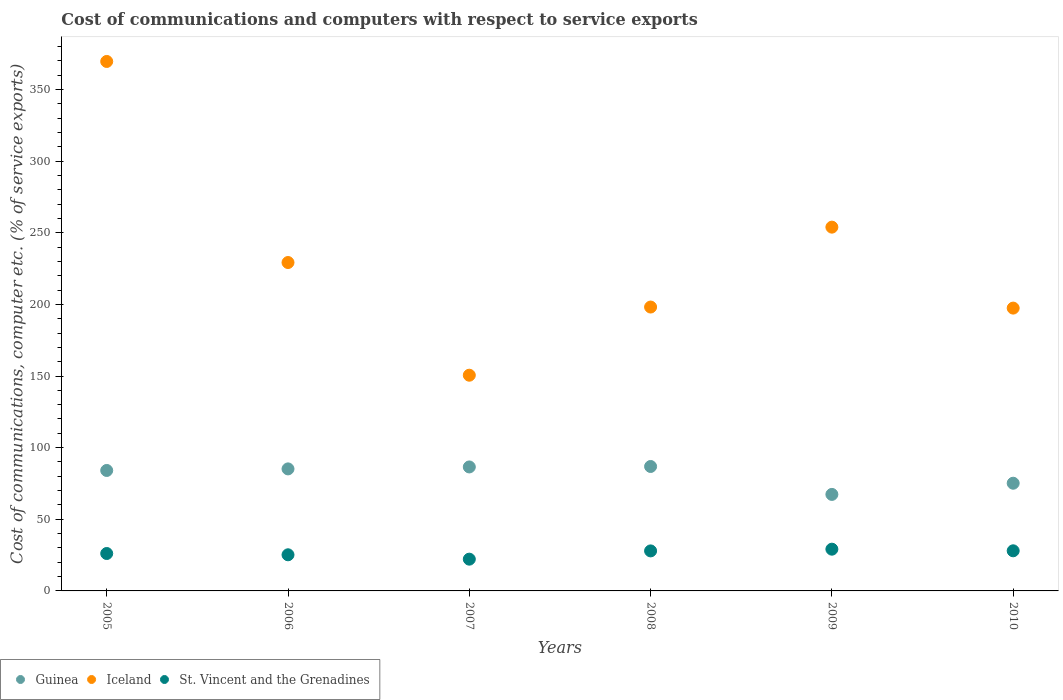How many different coloured dotlines are there?
Ensure brevity in your answer.  3. Is the number of dotlines equal to the number of legend labels?
Keep it short and to the point. Yes. What is the cost of communications and computers in St. Vincent and the Grenadines in 2008?
Ensure brevity in your answer.  27.93. Across all years, what is the maximum cost of communications and computers in Iceland?
Your answer should be very brief. 369.54. Across all years, what is the minimum cost of communications and computers in Guinea?
Your response must be concise. 67.36. In which year was the cost of communications and computers in St. Vincent and the Grenadines minimum?
Your answer should be compact. 2007. What is the total cost of communications and computers in Guinea in the graph?
Offer a very short reply. 485.15. What is the difference between the cost of communications and computers in Guinea in 2008 and that in 2009?
Offer a very short reply. 19.49. What is the difference between the cost of communications and computers in Iceland in 2006 and the cost of communications and computers in St. Vincent and the Grenadines in 2007?
Ensure brevity in your answer.  207.04. What is the average cost of communications and computers in Iceland per year?
Provide a short and direct response. 233.12. In the year 2009, what is the difference between the cost of communications and computers in Iceland and cost of communications and computers in Guinea?
Make the answer very short. 186.54. What is the ratio of the cost of communications and computers in St. Vincent and the Grenadines in 2006 to that in 2009?
Make the answer very short. 0.87. Is the difference between the cost of communications and computers in Iceland in 2009 and 2010 greater than the difference between the cost of communications and computers in Guinea in 2009 and 2010?
Your answer should be compact. Yes. What is the difference between the highest and the second highest cost of communications and computers in St. Vincent and the Grenadines?
Your response must be concise. 1.13. What is the difference between the highest and the lowest cost of communications and computers in St. Vincent and the Grenadines?
Give a very brief answer. 6.97. Is it the case that in every year, the sum of the cost of communications and computers in St. Vincent and the Grenadines and cost of communications and computers in Iceland  is greater than the cost of communications and computers in Guinea?
Ensure brevity in your answer.  Yes. Does the cost of communications and computers in Guinea monotonically increase over the years?
Provide a succinct answer. No. What is the difference between two consecutive major ticks on the Y-axis?
Your response must be concise. 50. Are the values on the major ticks of Y-axis written in scientific E-notation?
Offer a terse response. No. Does the graph contain any zero values?
Keep it short and to the point. No. Does the graph contain grids?
Make the answer very short. No. How many legend labels are there?
Provide a succinct answer. 3. How are the legend labels stacked?
Offer a very short reply. Horizontal. What is the title of the graph?
Make the answer very short. Cost of communications and computers with respect to service exports. Does "World" appear as one of the legend labels in the graph?
Provide a short and direct response. No. What is the label or title of the X-axis?
Your answer should be compact. Years. What is the label or title of the Y-axis?
Provide a succinct answer. Cost of communications, computer etc. (% of service exports). What is the Cost of communications, computer etc. (% of service exports) of Guinea in 2005?
Offer a terse response. 84.08. What is the Cost of communications, computer etc. (% of service exports) in Iceland in 2005?
Provide a short and direct response. 369.54. What is the Cost of communications, computer etc. (% of service exports) in St. Vincent and the Grenadines in 2005?
Give a very brief answer. 26.12. What is the Cost of communications, computer etc. (% of service exports) in Guinea in 2006?
Your response must be concise. 85.17. What is the Cost of communications, computer etc. (% of service exports) in Iceland in 2006?
Provide a succinct answer. 229.21. What is the Cost of communications, computer etc. (% of service exports) in St. Vincent and the Grenadines in 2006?
Make the answer very short. 25.22. What is the Cost of communications, computer etc. (% of service exports) of Guinea in 2007?
Give a very brief answer. 86.53. What is the Cost of communications, computer etc. (% of service exports) of Iceland in 2007?
Keep it short and to the point. 150.55. What is the Cost of communications, computer etc. (% of service exports) of St. Vincent and the Grenadines in 2007?
Provide a short and direct response. 22.17. What is the Cost of communications, computer etc. (% of service exports) in Guinea in 2008?
Your answer should be very brief. 86.85. What is the Cost of communications, computer etc. (% of service exports) in Iceland in 2008?
Give a very brief answer. 198.13. What is the Cost of communications, computer etc. (% of service exports) of St. Vincent and the Grenadines in 2008?
Offer a very short reply. 27.93. What is the Cost of communications, computer etc. (% of service exports) in Guinea in 2009?
Keep it short and to the point. 67.36. What is the Cost of communications, computer etc. (% of service exports) in Iceland in 2009?
Provide a succinct answer. 253.9. What is the Cost of communications, computer etc. (% of service exports) in St. Vincent and the Grenadines in 2009?
Provide a succinct answer. 29.14. What is the Cost of communications, computer etc. (% of service exports) in Guinea in 2010?
Offer a very short reply. 75.16. What is the Cost of communications, computer etc. (% of service exports) of Iceland in 2010?
Keep it short and to the point. 197.4. What is the Cost of communications, computer etc. (% of service exports) in St. Vincent and the Grenadines in 2010?
Make the answer very short. 28. Across all years, what is the maximum Cost of communications, computer etc. (% of service exports) of Guinea?
Make the answer very short. 86.85. Across all years, what is the maximum Cost of communications, computer etc. (% of service exports) in Iceland?
Keep it short and to the point. 369.54. Across all years, what is the maximum Cost of communications, computer etc. (% of service exports) of St. Vincent and the Grenadines?
Provide a succinct answer. 29.14. Across all years, what is the minimum Cost of communications, computer etc. (% of service exports) in Guinea?
Provide a succinct answer. 67.36. Across all years, what is the minimum Cost of communications, computer etc. (% of service exports) in Iceland?
Your response must be concise. 150.55. Across all years, what is the minimum Cost of communications, computer etc. (% of service exports) in St. Vincent and the Grenadines?
Provide a short and direct response. 22.17. What is the total Cost of communications, computer etc. (% of service exports) of Guinea in the graph?
Make the answer very short. 485.15. What is the total Cost of communications, computer etc. (% of service exports) of Iceland in the graph?
Offer a very short reply. 1398.74. What is the total Cost of communications, computer etc. (% of service exports) in St. Vincent and the Grenadines in the graph?
Ensure brevity in your answer.  158.57. What is the difference between the Cost of communications, computer etc. (% of service exports) in Guinea in 2005 and that in 2006?
Make the answer very short. -1.09. What is the difference between the Cost of communications, computer etc. (% of service exports) in Iceland in 2005 and that in 2006?
Make the answer very short. 140.33. What is the difference between the Cost of communications, computer etc. (% of service exports) in St. Vincent and the Grenadines in 2005 and that in 2006?
Provide a short and direct response. 0.9. What is the difference between the Cost of communications, computer etc. (% of service exports) of Guinea in 2005 and that in 2007?
Offer a terse response. -2.45. What is the difference between the Cost of communications, computer etc. (% of service exports) of Iceland in 2005 and that in 2007?
Keep it short and to the point. 218.99. What is the difference between the Cost of communications, computer etc. (% of service exports) of St. Vincent and the Grenadines in 2005 and that in 2007?
Provide a short and direct response. 3.95. What is the difference between the Cost of communications, computer etc. (% of service exports) in Guinea in 2005 and that in 2008?
Provide a succinct answer. -2.78. What is the difference between the Cost of communications, computer etc. (% of service exports) in Iceland in 2005 and that in 2008?
Give a very brief answer. 171.41. What is the difference between the Cost of communications, computer etc. (% of service exports) in St. Vincent and the Grenadines in 2005 and that in 2008?
Give a very brief answer. -1.81. What is the difference between the Cost of communications, computer etc. (% of service exports) of Guinea in 2005 and that in 2009?
Your response must be concise. 16.72. What is the difference between the Cost of communications, computer etc. (% of service exports) of Iceland in 2005 and that in 2009?
Provide a succinct answer. 115.64. What is the difference between the Cost of communications, computer etc. (% of service exports) in St. Vincent and the Grenadines in 2005 and that in 2009?
Your answer should be compact. -3.02. What is the difference between the Cost of communications, computer etc. (% of service exports) in Guinea in 2005 and that in 2010?
Give a very brief answer. 8.91. What is the difference between the Cost of communications, computer etc. (% of service exports) of Iceland in 2005 and that in 2010?
Your answer should be very brief. 172.15. What is the difference between the Cost of communications, computer etc. (% of service exports) in St. Vincent and the Grenadines in 2005 and that in 2010?
Offer a very short reply. -1.89. What is the difference between the Cost of communications, computer etc. (% of service exports) in Guinea in 2006 and that in 2007?
Provide a short and direct response. -1.36. What is the difference between the Cost of communications, computer etc. (% of service exports) of Iceland in 2006 and that in 2007?
Make the answer very short. 78.66. What is the difference between the Cost of communications, computer etc. (% of service exports) in St. Vincent and the Grenadines in 2006 and that in 2007?
Give a very brief answer. 3.05. What is the difference between the Cost of communications, computer etc. (% of service exports) of Guinea in 2006 and that in 2008?
Keep it short and to the point. -1.68. What is the difference between the Cost of communications, computer etc. (% of service exports) in Iceland in 2006 and that in 2008?
Keep it short and to the point. 31.08. What is the difference between the Cost of communications, computer etc. (% of service exports) of St. Vincent and the Grenadines in 2006 and that in 2008?
Make the answer very short. -2.71. What is the difference between the Cost of communications, computer etc. (% of service exports) in Guinea in 2006 and that in 2009?
Ensure brevity in your answer.  17.81. What is the difference between the Cost of communications, computer etc. (% of service exports) in Iceland in 2006 and that in 2009?
Your response must be concise. -24.69. What is the difference between the Cost of communications, computer etc. (% of service exports) of St. Vincent and the Grenadines in 2006 and that in 2009?
Provide a short and direct response. -3.92. What is the difference between the Cost of communications, computer etc. (% of service exports) of Guinea in 2006 and that in 2010?
Your answer should be compact. 10. What is the difference between the Cost of communications, computer etc. (% of service exports) in Iceland in 2006 and that in 2010?
Your response must be concise. 31.82. What is the difference between the Cost of communications, computer etc. (% of service exports) in St. Vincent and the Grenadines in 2006 and that in 2010?
Offer a very short reply. -2.79. What is the difference between the Cost of communications, computer etc. (% of service exports) of Guinea in 2007 and that in 2008?
Keep it short and to the point. -0.32. What is the difference between the Cost of communications, computer etc. (% of service exports) in Iceland in 2007 and that in 2008?
Provide a short and direct response. -47.58. What is the difference between the Cost of communications, computer etc. (% of service exports) of St. Vincent and the Grenadines in 2007 and that in 2008?
Offer a very short reply. -5.76. What is the difference between the Cost of communications, computer etc. (% of service exports) in Guinea in 2007 and that in 2009?
Your answer should be very brief. 19.17. What is the difference between the Cost of communications, computer etc. (% of service exports) of Iceland in 2007 and that in 2009?
Your answer should be very brief. -103.35. What is the difference between the Cost of communications, computer etc. (% of service exports) of St. Vincent and the Grenadines in 2007 and that in 2009?
Offer a very short reply. -6.97. What is the difference between the Cost of communications, computer etc. (% of service exports) of Guinea in 2007 and that in 2010?
Your response must be concise. 11.37. What is the difference between the Cost of communications, computer etc. (% of service exports) of Iceland in 2007 and that in 2010?
Your answer should be very brief. -46.84. What is the difference between the Cost of communications, computer etc. (% of service exports) of St. Vincent and the Grenadines in 2007 and that in 2010?
Offer a very short reply. -5.83. What is the difference between the Cost of communications, computer etc. (% of service exports) in Guinea in 2008 and that in 2009?
Provide a succinct answer. 19.49. What is the difference between the Cost of communications, computer etc. (% of service exports) in Iceland in 2008 and that in 2009?
Make the answer very short. -55.77. What is the difference between the Cost of communications, computer etc. (% of service exports) of St. Vincent and the Grenadines in 2008 and that in 2009?
Ensure brevity in your answer.  -1.21. What is the difference between the Cost of communications, computer etc. (% of service exports) of Guinea in 2008 and that in 2010?
Your answer should be very brief. 11.69. What is the difference between the Cost of communications, computer etc. (% of service exports) of Iceland in 2008 and that in 2010?
Offer a terse response. 0.74. What is the difference between the Cost of communications, computer etc. (% of service exports) of St. Vincent and the Grenadines in 2008 and that in 2010?
Provide a succinct answer. -0.07. What is the difference between the Cost of communications, computer etc. (% of service exports) of Guinea in 2009 and that in 2010?
Provide a succinct answer. -7.81. What is the difference between the Cost of communications, computer etc. (% of service exports) in Iceland in 2009 and that in 2010?
Your answer should be compact. 56.51. What is the difference between the Cost of communications, computer etc. (% of service exports) in St. Vincent and the Grenadines in 2009 and that in 2010?
Offer a very short reply. 1.13. What is the difference between the Cost of communications, computer etc. (% of service exports) in Guinea in 2005 and the Cost of communications, computer etc. (% of service exports) in Iceland in 2006?
Offer a terse response. -145.14. What is the difference between the Cost of communications, computer etc. (% of service exports) in Guinea in 2005 and the Cost of communications, computer etc. (% of service exports) in St. Vincent and the Grenadines in 2006?
Provide a succinct answer. 58.86. What is the difference between the Cost of communications, computer etc. (% of service exports) of Iceland in 2005 and the Cost of communications, computer etc. (% of service exports) of St. Vincent and the Grenadines in 2006?
Provide a succinct answer. 344.33. What is the difference between the Cost of communications, computer etc. (% of service exports) in Guinea in 2005 and the Cost of communications, computer etc. (% of service exports) in Iceland in 2007?
Provide a short and direct response. -66.48. What is the difference between the Cost of communications, computer etc. (% of service exports) in Guinea in 2005 and the Cost of communications, computer etc. (% of service exports) in St. Vincent and the Grenadines in 2007?
Your response must be concise. 61.91. What is the difference between the Cost of communications, computer etc. (% of service exports) in Iceland in 2005 and the Cost of communications, computer etc. (% of service exports) in St. Vincent and the Grenadines in 2007?
Your answer should be compact. 347.37. What is the difference between the Cost of communications, computer etc. (% of service exports) of Guinea in 2005 and the Cost of communications, computer etc. (% of service exports) of Iceland in 2008?
Give a very brief answer. -114.06. What is the difference between the Cost of communications, computer etc. (% of service exports) of Guinea in 2005 and the Cost of communications, computer etc. (% of service exports) of St. Vincent and the Grenadines in 2008?
Offer a terse response. 56.15. What is the difference between the Cost of communications, computer etc. (% of service exports) of Iceland in 2005 and the Cost of communications, computer etc. (% of service exports) of St. Vincent and the Grenadines in 2008?
Provide a succinct answer. 341.61. What is the difference between the Cost of communications, computer etc. (% of service exports) in Guinea in 2005 and the Cost of communications, computer etc. (% of service exports) in Iceland in 2009?
Offer a terse response. -169.83. What is the difference between the Cost of communications, computer etc. (% of service exports) in Guinea in 2005 and the Cost of communications, computer etc. (% of service exports) in St. Vincent and the Grenadines in 2009?
Provide a succinct answer. 54.94. What is the difference between the Cost of communications, computer etc. (% of service exports) in Iceland in 2005 and the Cost of communications, computer etc. (% of service exports) in St. Vincent and the Grenadines in 2009?
Your answer should be compact. 340.41. What is the difference between the Cost of communications, computer etc. (% of service exports) in Guinea in 2005 and the Cost of communications, computer etc. (% of service exports) in Iceland in 2010?
Give a very brief answer. -113.32. What is the difference between the Cost of communications, computer etc. (% of service exports) of Guinea in 2005 and the Cost of communications, computer etc. (% of service exports) of St. Vincent and the Grenadines in 2010?
Give a very brief answer. 56.07. What is the difference between the Cost of communications, computer etc. (% of service exports) in Iceland in 2005 and the Cost of communications, computer etc. (% of service exports) in St. Vincent and the Grenadines in 2010?
Make the answer very short. 341.54. What is the difference between the Cost of communications, computer etc. (% of service exports) in Guinea in 2006 and the Cost of communications, computer etc. (% of service exports) in Iceland in 2007?
Offer a very short reply. -65.39. What is the difference between the Cost of communications, computer etc. (% of service exports) in Guinea in 2006 and the Cost of communications, computer etc. (% of service exports) in St. Vincent and the Grenadines in 2007?
Ensure brevity in your answer.  63. What is the difference between the Cost of communications, computer etc. (% of service exports) in Iceland in 2006 and the Cost of communications, computer etc. (% of service exports) in St. Vincent and the Grenadines in 2007?
Provide a short and direct response. 207.04. What is the difference between the Cost of communications, computer etc. (% of service exports) of Guinea in 2006 and the Cost of communications, computer etc. (% of service exports) of Iceland in 2008?
Keep it short and to the point. -112.97. What is the difference between the Cost of communications, computer etc. (% of service exports) of Guinea in 2006 and the Cost of communications, computer etc. (% of service exports) of St. Vincent and the Grenadines in 2008?
Provide a short and direct response. 57.24. What is the difference between the Cost of communications, computer etc. (% of service exports) in Iceland in 2006 and the Cost of communications, computer etc. (% of service exports) in St. Vincent and the Grenadines in 2008?
Offer a very short reply. 201.28. What is the difference between the Cost of communications, computer etc. (% of service exports) of Guinea in 2006 and the Cost of communications, computer etc. (% of service exports) of Iceland in 2009?
Provide a succinct answer. -168.73. What is the difference between the Cost of communications, computer etc. (% of service exports) of Guinea in 2006 and the Cost of communications, computer etc. (% of service exports) of St. Vincent and the Grenadines in 2009?
Make the answer very short. 56.03. What is the difference between the Cost of communications, computer etc. (% of service exports) in Iceland in 2006 and the Cost of communications, computer etc. (% of service exports) in St. Vincent and the Grenadines in 2009?
Provide a succinct answer. 200.08. What is the difference between the Cost of communications, computer etc. (% of service exports) in Guinea in 2006 and the Cost of communications, computer etc. (% of service exports) in Iceland in 2010?
Ensure brevity in your answer.  -112.23. What is the difference between the Cost of communications, computer etc. (% of service exports) in Guinea in 2006 and the Cost of communications, computer etc. (% of service exports) in St. Vincent and the Grenadines in 2010?
Your response must be concise. 57.16. What is the difference between the Cost of communications, computer etc. (% of service exports) in Iceland in 2006 and the Cost of communications, computer etc. (% of service exports) in St. Vincent and the Grenadines in 2010?
Offer a terse response. 201.21. What is the difference between the Cost of communications, computer etc. (% of service exports) of Guinea in 2007 and the Cost of communications, computer etc. (% of service exports) of Iceland in 2008?
Your answer should be compact. -111.6. What is the difference between the Cost of communications, computer etc. (% of service exports) in Guinea in 2007 and the Cost of communications, computer etc. (% of service exports) in St. Vincent and the Grenadines in 2008?
Your response must be concise. 58.6. What is the difference between the Cost of communications, computer etc. (% of service exports) of Iceland in 2007 and the Cost of communications, computer etc. (% of service exports) of St. Vincent and the Grenadines in 2008?
Offer a very short reply. 122.62. What is the difference between the Cost of communications, computer etc. (% of service exports) of Guinea in 2007 and the Cost of communications, computer etc. (% of service exports) of Iceland in 2009?
Offer a terse response. -167.37. What is the difference between the Cost of communications, computer etc. (% of service exports) of Guinea in 2007 and the Cost of communications, computer etc. (% of service exports) of St. Vincent and the Grenadines in 2009?
Provide a succinct answer. 57.39. What is the difference between the Cost of communications, computer etc. (% of service exports) in Iceland in 2007 and the Cost of communications, computer etc. (% of service exports) in St. Vincent and the Grenadines in 2009?
Provide a succinct answer. 121.42. What is the difference between the Cost of communications, computer etc. (% of service exports) of Guinea in 2007 and the Cost of communications, computer etc. (% of service exports) of Iceland in 2010?
Your answer should be very brief. -110.87. What is the difference between the Cost of communications, computer etc. (% of service exports) of Guinea in 2007 and the Cost of communications, computer etc. (% of service exports) of St. Vincent and the Grenadines in 2010?
Ensure brevity in your answer.  58.53. What is the difference between the Cost of communications, computer etc. (% of service exports) in Iceland in 2007 and the Cost of communications, computer etc. (% of service exports) in St. Vincent and the Grenadines in 2010?
Make the answer very short. 122.55. What is the difference between the Cost of communications, computer etc. (% of service exports) of Guinea in 2008 and the Cost of communications, computer etc. (% of service exports) of Iceland in 2009?
Make the answer very short. -167.05. What is the difference between the Cost of communications, computer etc. (% of service exports) of Guinea in 2008 and the Cost of communications, computer etc. (% of service exports) of St. Vincent and the Grenadines in 2009?
Keep it short and to the point. 57.72. What is the difference between the Cost of communications, computer etc. (% of service exports) of Iceland in 2008 and the Cost of communications, computer etc. (% of service exports) of St. Vincent and the Grenadines in 2009?
Offer a very short reply. 169. What is the difference between the Cost of communications, computer etc. (% of service exports) in Guinea in 2008 and the Cost of communications, computer etc. (% of service exports) in Iceland in 2010?
Give a very brief answer. -110.54. What is the difference between the Cost of communications, computer etc. (% of service exports) in Guinea in 2008 and the Cost of communications, computer etc. (% of service exports) in St. Vincent and the Grenadines in 2010?
Your answer should be compact. 58.85. What is the difference between the Cost of communications, computer etc. (% of service exports) in Iceland in 2008 and the Cost of communications, computer etc. (% of service exports) in St. Vincent and the Grenadines in 2010?
Your answer should be compact. 170.13. What is the difference between the Cost of communications, computer etc. (% of service exports) in Guinea in 2009 and the Cost of communications, computer etc. (% of service exports) in Iceland in 2010?
Offer a terse response. -130.04. What is the difference between the Cost of communications, computer etc. (% of service exports) in Guinea in 2009 and the Cost of communications, computer etc. (% of service exports) in St. Vincent and the Grenadines in 2010?
Your answer should be compact. 39.36. What is the difference between the Cost of communications, computer etc. (% of service exports) of Iceland in 2009 and the Cost of communications, computer etc. (% of service exports) of St. Vincent and the Grenadines in 2010?
Provide a succinct answer. 225.9. What is the average Cost of communications, computer etc. (% of service exports) in Guinea per year?
Keep it short and to the point. 80.86. What is the average Cost of communications, computer etc. (% of service exports) of Iceland per year?
Provide a short and direct response. 233.12. What is the average Cost of communications, computer etc. (% of service exports) of St. Vincent and the Grenadines per year?
Your response must be concise. 26.43. In the year 2005, what is the difference between the Cost of communications, computer etc. (% of service exports) in Guinea and Cost of communications, computer etc. (% of service exports) in Iceland?
Make the answer very short. -285.47. In the year 2005, what is the difference between the Cost of communications, computer etc. (% of service exports) in Guinea and Cost of communications, computer etc. (% of service exports) in St. Vincent and the Grenadines?
Give a very brief answer. 57.96. In the year 2005, what is the difference between the Cost of communications, computer etc. (% of service exports) of Iceland and Cost of communications, computer etc. (% of service exports) of St. Vincent and the Grenadines?
Offer a terse response. 343.43. In the year 2006, what is the difference between the Cost of communications, computer etc. (% of service exports) of Guinea and Cost of communications, computer etc. (% of service exports) of Iceland?
Make the answer very short. -144.04. In the year 2006, what is the difference between the Cost of communications, computer etc. (% of service exports) of Guinea and Cost of communications, computer etc. (% of service exports) of St. Vincent and the Grenadines?
Ensure brevity in your answer.  59.95. In the year 2006, what is the difference between the Cost of communications, computer etc. (% of service exports) in Iceland and Cost of communications, computer etc. (% of service exports) in St. Vincent and the Grenadines?
Provide a short and direct response. 203.99. In the year 2007, what is the difference between the Cost of communications, computer etc. (% of service exports) of Guinea and Cost of communications, computer etc. (% of service exports) of Iceland?
Provide a short and direct response. -64.02. In the year 2007, what is the difference between the Cost of communications, computer etc. (% of service exports) of Guinea and Cost of communications, computer etc. (% of service exports) of St. Vincent and the Grenadines?
Provide a short and direct response. 64.36. In the year 2007, what is the difference between the Cost of communications, computer etc. (% of service exports) in Iceland and Cost of communications, computer etc. (% of service exports) in St. Vincent and the Grenadines?
Your answer should be compact. 128.39. In the year 2008, what is the difference between the Cost of communications, computer etc. (% of service exports) in Guinea and Cost of communications, computer etc. (% of service exports) in Iceland?
Offer a very short reply. -111.28. In the year 2008, what is the difference between the Cost of communications, computer etc. (% of service exports) in Guinea and Cost of communications, computer etc. (% of service exports) in St. Vincent and the Grenadines?
Make the answer very short. 58.92. In the year 2008, what is the difference between the Cost of communications, computer etc. (% of service exports) of Iceland and Cost of communications, computer etc. (% of service exports) of St. Vincent and the Grenadines?
Keep it short and to the point. 170.2. In the year 2009, what is the difference between the Cost of communications, computer etc. (% of service exports) of Guinea and Cost of communications, computer etc. (% of service exports) of Iceland?
Offer a very short reply. -186.54. In the year 2009, what is the difference between the Cost of communications, computer etc. (% of service exports) of Guinea and Cost of communications, computer etc. (% of service exports) of St. Vincent and the Grenadines?
Your answer should be very brief. 38.22. In the year 2009, what is the difference between the Cost of communications, computer etc. (% of service exports) of Iceland and Cost of communications, computer etc. (% of service exports) of St. Vincent and the Grenadines?
Your response must be concise. 224.77. In the year 2010, what is the difference between the Cost of communications, computer etc. (% of service exports) of Guinea and Cost of communications, computer etc. (% of service exports) of Iceland?
Your answer should be compact. -122.23. In the year 2010, what is the difference between the Cost of communications, computer etc. (% of service exports) of Guinea and Cost of communications, computer etc. (% of service exports) of St. Vincent and the Grenadines?
Provide a succinct answer. 47.16. In the year 2010, what is the difference between the Cost of communications, computer etc. (% of service exports) of Iceland and Cost of communications, computer etc. (% of service exports) of St. Vincent and the Grenadines?
Your answer should be very brief. 169.39. What is the ratio of the Cost of communications, computer etc. (% of service exports) in Guinea in 2005 to that in 2006?
Your answer should be very brief. 0.99. What is the ratio of the Cost of communications, computer etc. (% of service exports) of Iceland in 2005 to that in 2006?
Give a very brief answer. 1.61. What is the ratio of the Cost of communications, computer etc. (% of service exports) of St. Vincent and the Grenadines in 2005 to that in 2006?
Your answer should be compact. 1.04. What is the ratio of the Cost of communications, computer etc. (% of service exports) in Guinea in 2005 to that in 2007?
Provide a succinct answer. 0.97. What is the ratio of the Cost of communications, computer etc. (% of service exports) of Iceland in 2005 to that in 2007?
Keep it short and to the point. 2.45. What is the ratio of the Cost of communications, computer etc. (% of service exports) in St. Vincent and the Grenadines in 2005 to that in 2007?
Give a very brief answer. 1.18. What is the ratio of the Cost of communications, computer etc. (% of service exports) in Guinea in 2005 to that in 2008?
Keep it short and to the point. 0.97. What is the ratio of the Cost of communications, computer etc. (% of service exports) of Iceland in 2005 to that in 2008?
Ensure brevity in your answer.  1.87. What is the ratio of the Cost of communications, computer etc. (% of service exports) in St. Vincent and the Grenadines in 2005 to that in 2008?
Offer a terse response. 0.94. What is the ratio of the Cost of communications, computer etc. (% of service exports) in Guinea in 2005 to that in 2009?
Offer a terse response. 1.25. What is the ratio of the Cost of communications, computer etc. (% of service exports) in Iceland in 2005 to that in 2009?
Provide a short and direct response. 1.46. What is the ratio of the Cost of communications, computer etc. (% of service exports) of St. Vincent and the Grenadines in 2005 to that in 2009?
Make the answer very short. 0.9. What is the ratio of the Cost of communications, computer etc. (% of service exports) in Guinea in 2005 to that in 2010?
Offer a terse response. 1.12. What is the ratio of the Cost of communications, computer etc. (% of service exports) of Iceland in 2005 to that in 2010?
Offer a terse response. 1.87. What is the ratio of the Cost of communications, computer etc. (% of service exports) of St. Vincent and the Grenadines in 2005 to that in 2010?
Your answer should be very brief. 0.93. What is the ratio of the Cost of communications, computer etc. (% of service exports) of Guinea in 2006 to that in 2007?
Your answer should be very brief. 0.98. What is the ratio of the Cost of communications, computer etc. (% of service exports) of Iceland in 2006 to that in 2007?
Provide a short and direct response. 1.52. What is the ratio of the Cost of communications, computer etc. (% of service exports) of St. Vincent and the Grenadines in 2006 to that in 2007?
Your answer should be compact. 1.14. What is the ratio of the Cost of communications, computer etc. (% of service exports) of Guinea in 2006 to that in 2008?
Offer a very short reply. 0.98. What is the ratio of the Cost of communications, computer etc. (% of service exports) of Iceland in 2006 to that in 2008?
Offer a very short reply. 1.16. What is the ratio of the Cost of communications, computer etc. (% of service exports) of St. Vincent and the Grenadines in 2006 to that in 2008?
Your response must be concise. 0.9. What is the ratio of the Cost of communications, computer etc. (% of service exports) of Guinea in 2006 to that in 2009?
Make the answer very short. 1.26. What is the ratio of the Cost of communications, computer etc. (% of service exports) in Iceland in 2006 to that in 2009?
Your answer should be very brief. 0.9. What is the ratio of the Cost of communications, computer etc. (% of service exports) of St. Vincent and the Grenadines in 2006 to that in 2009?
Offer a very short reply. 0.87. What is the ratio of the Cost of communications, computer etc. (% of service exports) in Guinea in 2006 to that in 2010?
Your answer should be compact. 1.13. What is the ratio of the Cost of communications, computer etc. (% of service exports) in Iceland in 2006 to that in 2010?
Make the answer very short. 1.16. What is the ratio of the Cost of communications, computer etc. (% of service exports) in St. Vincent and the Grenadines in 2006 to that in 2010?
Make the answer very short. 0.9. What is the ratio of the Cost of communications, computer etc. (% of service exports) in Guinea in 2007 to that in 2008?
Provide a succinct answer. 1. What is the ratio of the Cost of communications, computer etc. (% of service exports) of Iceland in 2007 to that in 2008?
Give a very brief answer. 0.76. What is the ratio of the Cost of communications, computer etc. (% of service exports) of St. Vincent and the Grenadines in 2007 to that in 2008?
Ensure brevity in your answer.  0.79. What is the ratio of the Cost of communications, computer etc. (% of service exports) in Guinea in 2007 to that in 2009?
Give a very brief answer. 1.28. What is the ratio of the Cost of communications, computer etc. (% of service exports) in Iceland in 2007 to that in 2009?
Your answer should be very brief. 0.59. What is the ratio of the Cost of communications, computer etc. (% of service exports) of St. Vincent and the Grenadines in 2007 to that in 2009?
Your response must be concise. 0.76. What is the ratio of the Cost of communications, computer etc. (% of service exports) in Guinea in 2007 to that in 2010?
Provide a succinct answer. 1.15. What is the ratio of the Cost of communications, computer etc. (% of service exports) of Iceland in 2007 to that in 2010?
Provide a short and direct response. 0.76. What is the ratio of the Cost of communications, computer etc. (% of service exports) in St. Vincent and the Grenadines in 2007 to that in 2010?
Your answer should be very brief. 0.79. What is the ratio of the Cost of communications, computer etc. (% of service exports) of Guinea in 2008 to that in 2009?
Offer a terse response. 1.29. What is the ratio of the Cost of communications, computer etc. (% of service exports) of Iceland in 2008 to that in 2009?
Your response must be concise. 0.78. What is the ratio of the Cost of communications, computer etc. (% of service exports) in St. Vincent and the Grenadines in 2008 to that in 2009?
Give a very brief answer. 0.96. What is the ratio of the Cost of communications, computer etc. (% of service exports) in Guinea in 2008 to that in 2010?
Your answer should be very brief. 1.16. What is the ratio of the Cost of communications, computer etc. (% of service exports) of Iceland in 2008 to that in 2010?
Your answer should be very brief. 1. What is the ratio of the Cost of communications, computer etc. (% of service exports) in St. Vincent and the Grenadines in 2008 to that in 2010?
Make the answer very short. 1. What is the ratio of the Cost of communications, computer etc. (% of service exports) in Guinea in 2009 to that in 2010?
Keep it short and to the point. 0.9. What is the ratio of the Cost of communications, computer etc. (% of service exports) of Iceland in 2009 to that in 2010?
Your answer should be compact. 1.29. What is the ratio of the Cost of communications, computer etc. (% of service exports) of St. Vincent and the Grenadines in 2009 to that in 2010?
Your response must be concise. 1.04. What is the difference between the highest and the second highest Cost of communications, computer etc. (% of service exports) in Guinea?
Give a very brief answer. 0.32. What is the difference between the highest and the second highest Cost of communications, computer etc. (% of service exports) of Iceland?
Give a very brief answer. 115.64. What is the difference between the highest and the second highest Cost of communications, computer etc. (% of service exports) in St. Vincent and the Grenadines?
Provide a succinct answer. 1.13. What is the difference between the highest and the lowest Cost of communications, computer etc. (% of service exports) in Guinea?
Your answer should be very brief. 19.49. What is the difference between the highest and the lowest Cost of communications, computer etc. (% of service exports) of Iceland?
Your response must be concise. 218.99. What is the difference between the highest and the lowest Cost of communications, computer etc. (% of service exports) of St. Vincent and the Grenadines?
Your answer should be compact. 6.97. 